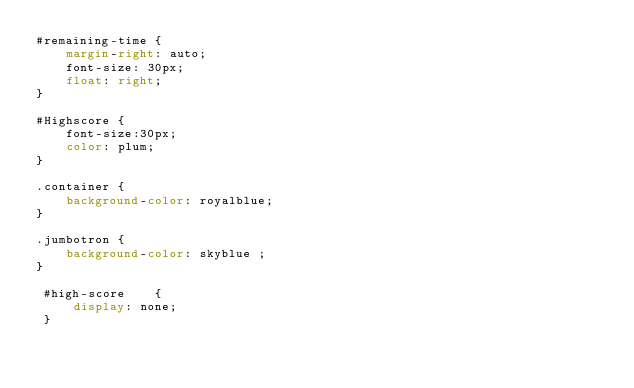<code> <loc_0><loc_0><loc_500><loc_500><_CSS_>#remaining-time {
    margin-right: auto;
    font-size: 30px;
    float: right;
}

#Highscore {
    font-size:30px;
    color: plum;
}

.container {
    background-color: royalblue;
}

.jumbotron {
    background-color: skyblue ;
}

 #high-score    {
     display: none;
 }

 </code> 